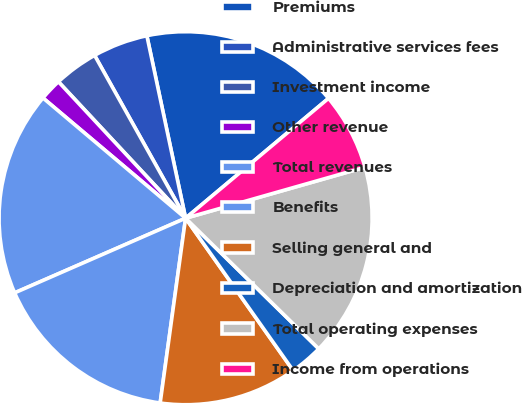Convert chart to OTSL. <chart><loc_0><loc_0><loc_500><loc_500><pie_chart><fcel>Premiums<fcel>Administrative services fees<fcel>Investment income<fcel>Other revenue<fcel>Total revenues<fcel>Benefits<fcel>Selling general and<fcel>Depreciation and amortization<fcel>Total operating expenses<fcel>Income from operations<nl><fcel>17.22%<fcel>4.78%<fcel>3.83%<fcel>1.91%<fcel>17.7%<fcel>16.27%<fcel>11.96%<fcel>2.87%<fcel>16.75%<fcel>6.7%<nl></chart> 